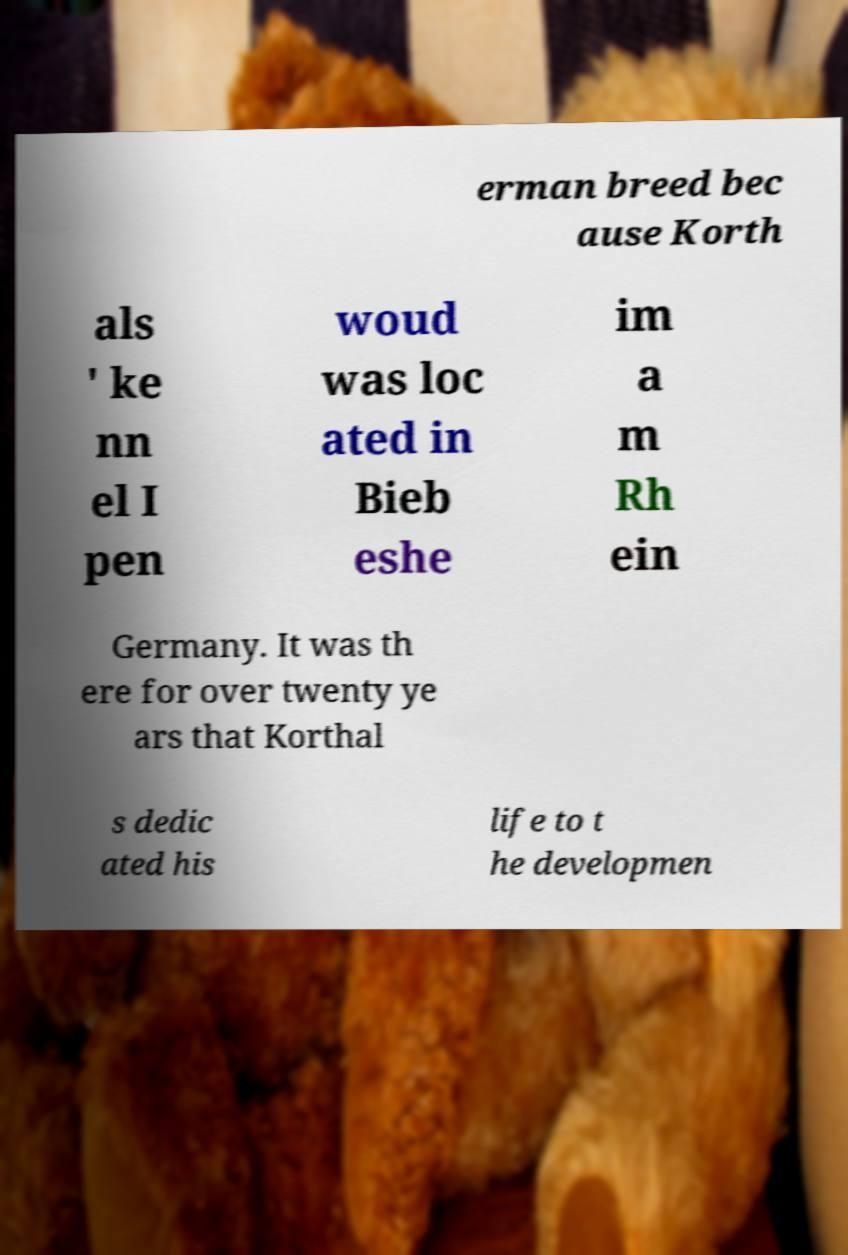For documentation purposes, I need the text within this image transcribed. Could you provide that? erman breed bec ause Korth als ' ke nn el I pen woud was loc ated in Bieb eshe im a m Rh ein Germany. It was th ere for over twenty ye ars that Korthal s dedic ated his life to t he developmen 